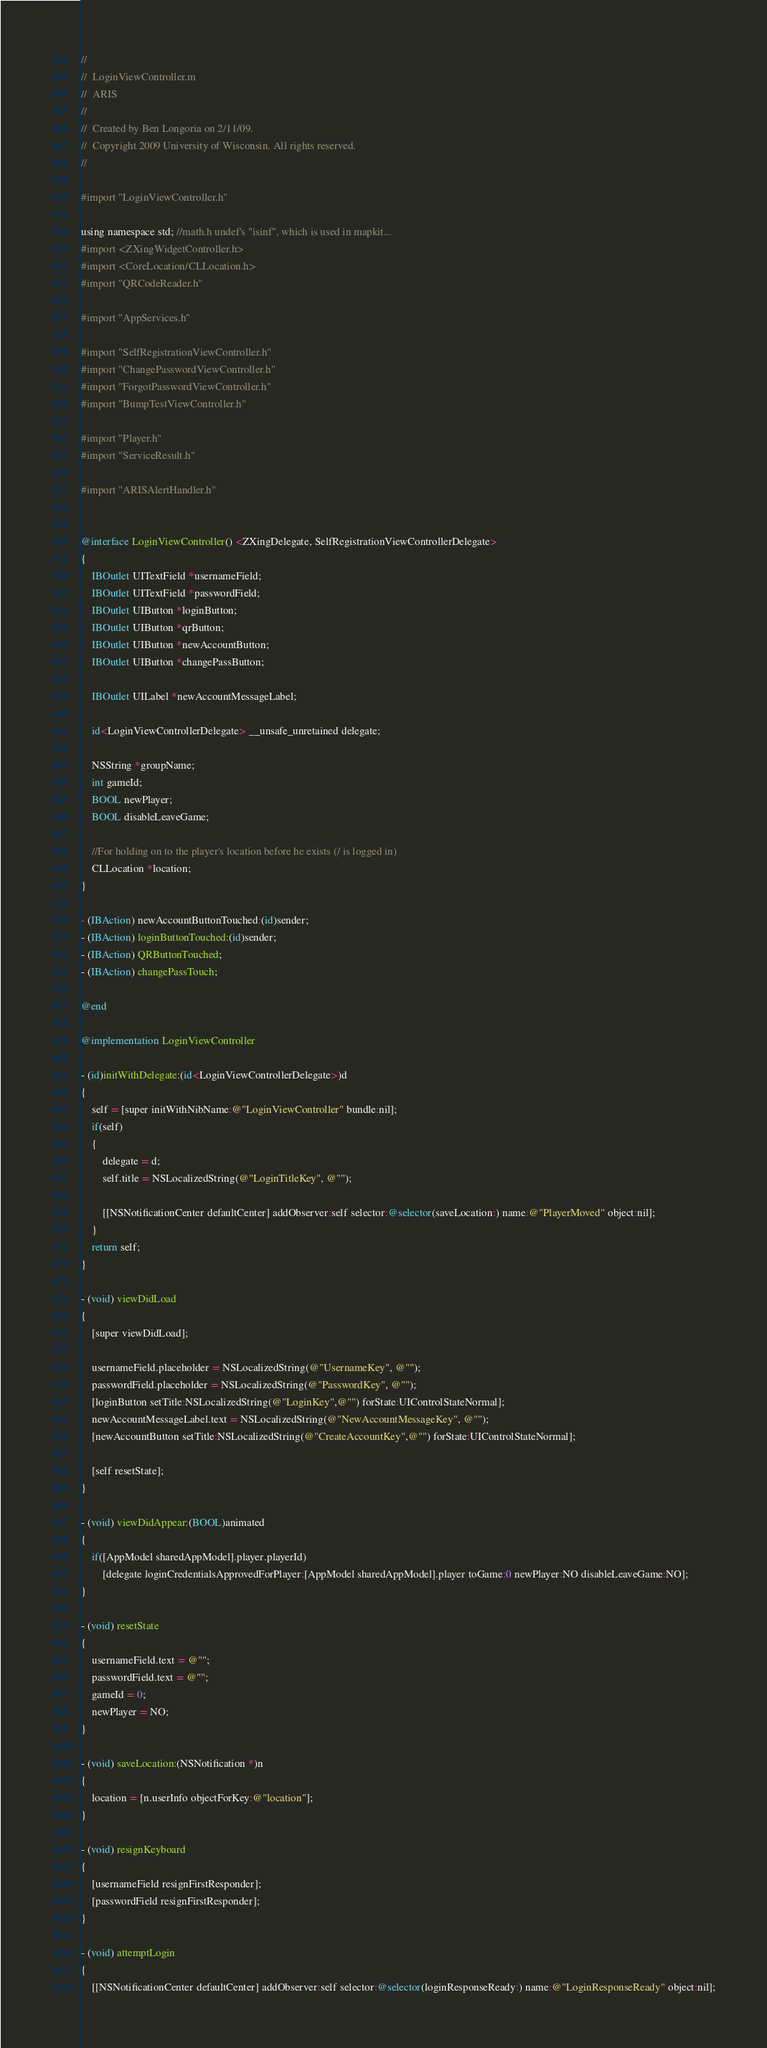Convert code to text. <code><loc_0><loc_0><loc_500><loc_500><_ObjectiveC_>//
//  LoginViewController.m
//  ARIS
//
//  Created by Ben Longoria on 2/11/09.
//  Copyright 2009 University of Wisconsin. All rights reserved.
//

#import "LoginViewController.h"

using namespace std; //math.h undef's "isinf", which is used in mapkit...
#import <ZXingWidgetController.h>
#import <CoreLocation/CLLocation.h>
#import "QRCodeReader.h"

#import "AppServices.h"

#import "SelfRegistrationViewController.h"
#import "ChangePasswordViewController.h"
#import "ForgotPasswordViewController.h"
#import "BumpTestViewController.h"

#import "Player.h"
#import "ServiceResult.h"

#import "ARISAlertHandler.h"


@interface LoginViewController() <ZXingDelegate, SelfRegistrationViewControllerDelegate>
{
    IBOutlet UITextField *usernameField;
	IBOutlet UITextField *passwordField;
	IBOutlet UIButton *loginButton;
    IBOutlet UIButton *qrButton;
	IBOutlet UIButton *newAccountButton;
    IBOutlet UIButton *changePassButton;
    
	IBOutlet UILabel *newAccountMessageLabel;
    
    id<LoginViewControllerDelegate> __unsafe_unretained delegate;
    
    NSString *groupName;
    int gameId;
    BOOL newPlayer;
    BOOL disableLeaveGame;
    
    //For holding on to the player's location before he exists (/ is logged in)
    CLLocation *location;
}

- (IBAction) newAccountButtonTouched:(id)sender;
- (IBAction) loginButtonTouched:(id)sender;
- (IBAction) QRButtonTouched;
- (IBAction) changePassTouch;

@end

@implementation LoginViewController

- (id)initWithDelegate:(id<LoginViewControllerDelegate>)d
{
    self = [super initWithNibName:@"LoginViewController" bundle:nil];
    if(self)
    {
        delegate = d;
        self.title = NSLocalizedString(@"LoginTitleKey", @"");
        
        [[NSNotificationCenter defaultCenter] addObserver:self selector:@selector(saveLocation:) name:@"PlayerMoved" object:nil];
    }
    return self;
}

- (void) viewDidLoad
{
    [super viewDidLoad];

    usernameField.placeholder = NSLocalizedString(@"UsernameKey", @"");
    passwordField.placeholder = NSLocalizedString(@"PasswordKey", @"");
    [loginButton setTitle:NSLocalizedString(@"LoginKey",@"") forState:UIControlStateNormal];
    newAccountMessageLabel.text = NSLocalizedString(@"NewAccountMessageKey", @"");
    [newAccountButton setTitle:NSLocalizedString(@"CreateAccountKey",@"") forState:UIControlStateNormal];
    
    [self resetState];
}

- (void) viewDidAppear:(BOOL)animated
{
    if([AppModel sharedAppModel].player.playerId)
        [delegate loginCredentialsApprovedForPlayer:[AppModel sharedAppModel].player toGame:0 newPlayer:NO disableLeaveGame:NO];
}

- (void) resetState
{
    usernameField.text = @"";
    passwordField.text = @"";
    gameId = 0;
    newPlayer = NO;
}

- (void) saveLocation:(NSNotification *)n
{
    location = [n.userInfo objectForKey:@"location"];
}

- (void) resignKeyboard
{
    [usernameField resignFirstResponder];
    [passwordField resignFirstResponder];
}

- (void) attemptLogin
{
    [[NSNotificationCenter defaultCenter] addObserver:self selector:@selector(loginResponseReady:) name:@"LoginResponseReady" object:nil];</code> 